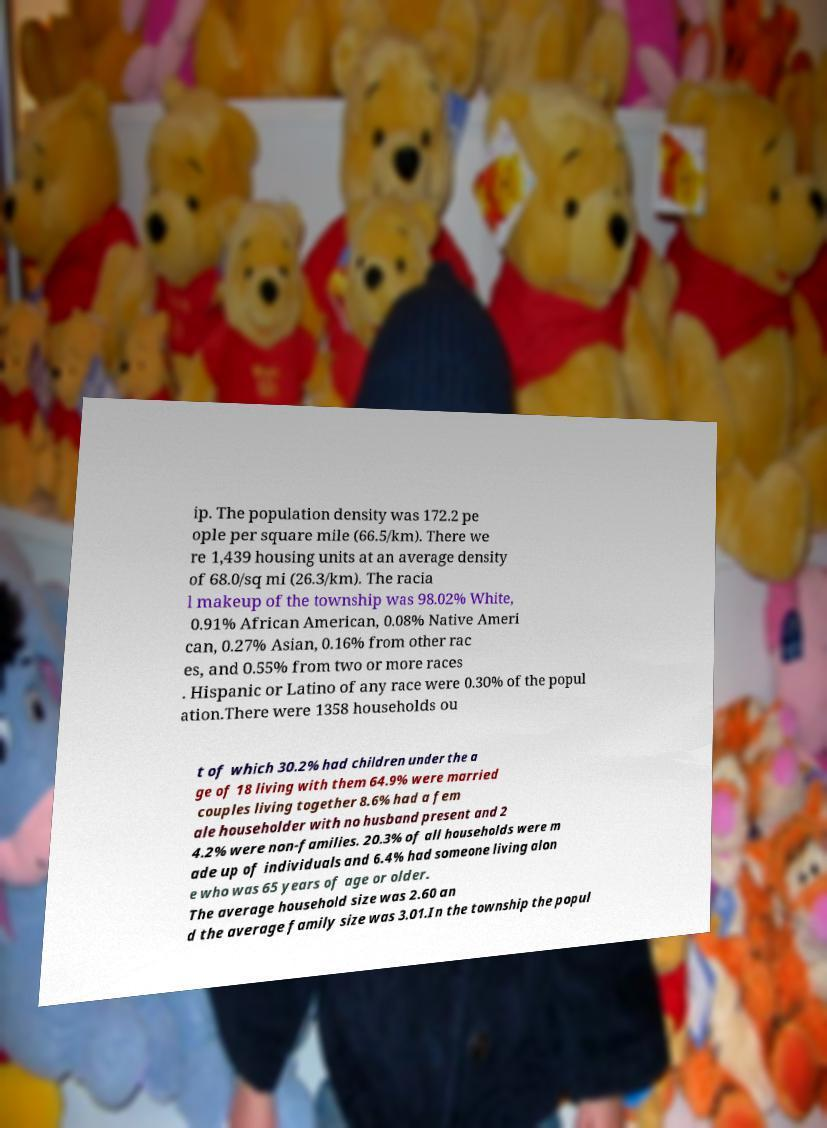Please read and relay the text visible in this image. What does it say? ip. The population density was 172.2 pe ople per square mile (66.5/km). There we re 1,439 housing units at an average density of 68.0/sq mi (26.3/km). The racia l makeup of the township was 98.02% White, 0.91% African American, 0.08% Native Ameri can, 0.27% Asian, 0.16% from other rac es, and 0.55% from two or more races . Hispanic or Latino of any race were 0.30% of the popul ation.There were 1358 households ou t of which 30.2% had children under the a ge of 18 living with them 64.9% were married couples living together 8.6% had a fem ale householder with no husband present and 2 4.2% were non-families. 20.3% of all households were m ade up of individuals and 6.4% had someone living alon e who was 65 years of age or older. The average household size was 2.60 an d the average family size was 3.01.In the township the popul 